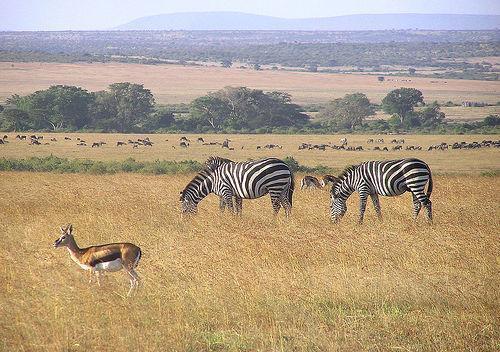How many zebras in the foreground?
Give a very brief answer. 2. How many zebra are pictured?
Give a very brief answer. 2. How many zebras are there?
Give a very brief answer. 2. How many zebras are on fire?
Give a very brief answer. 0. 